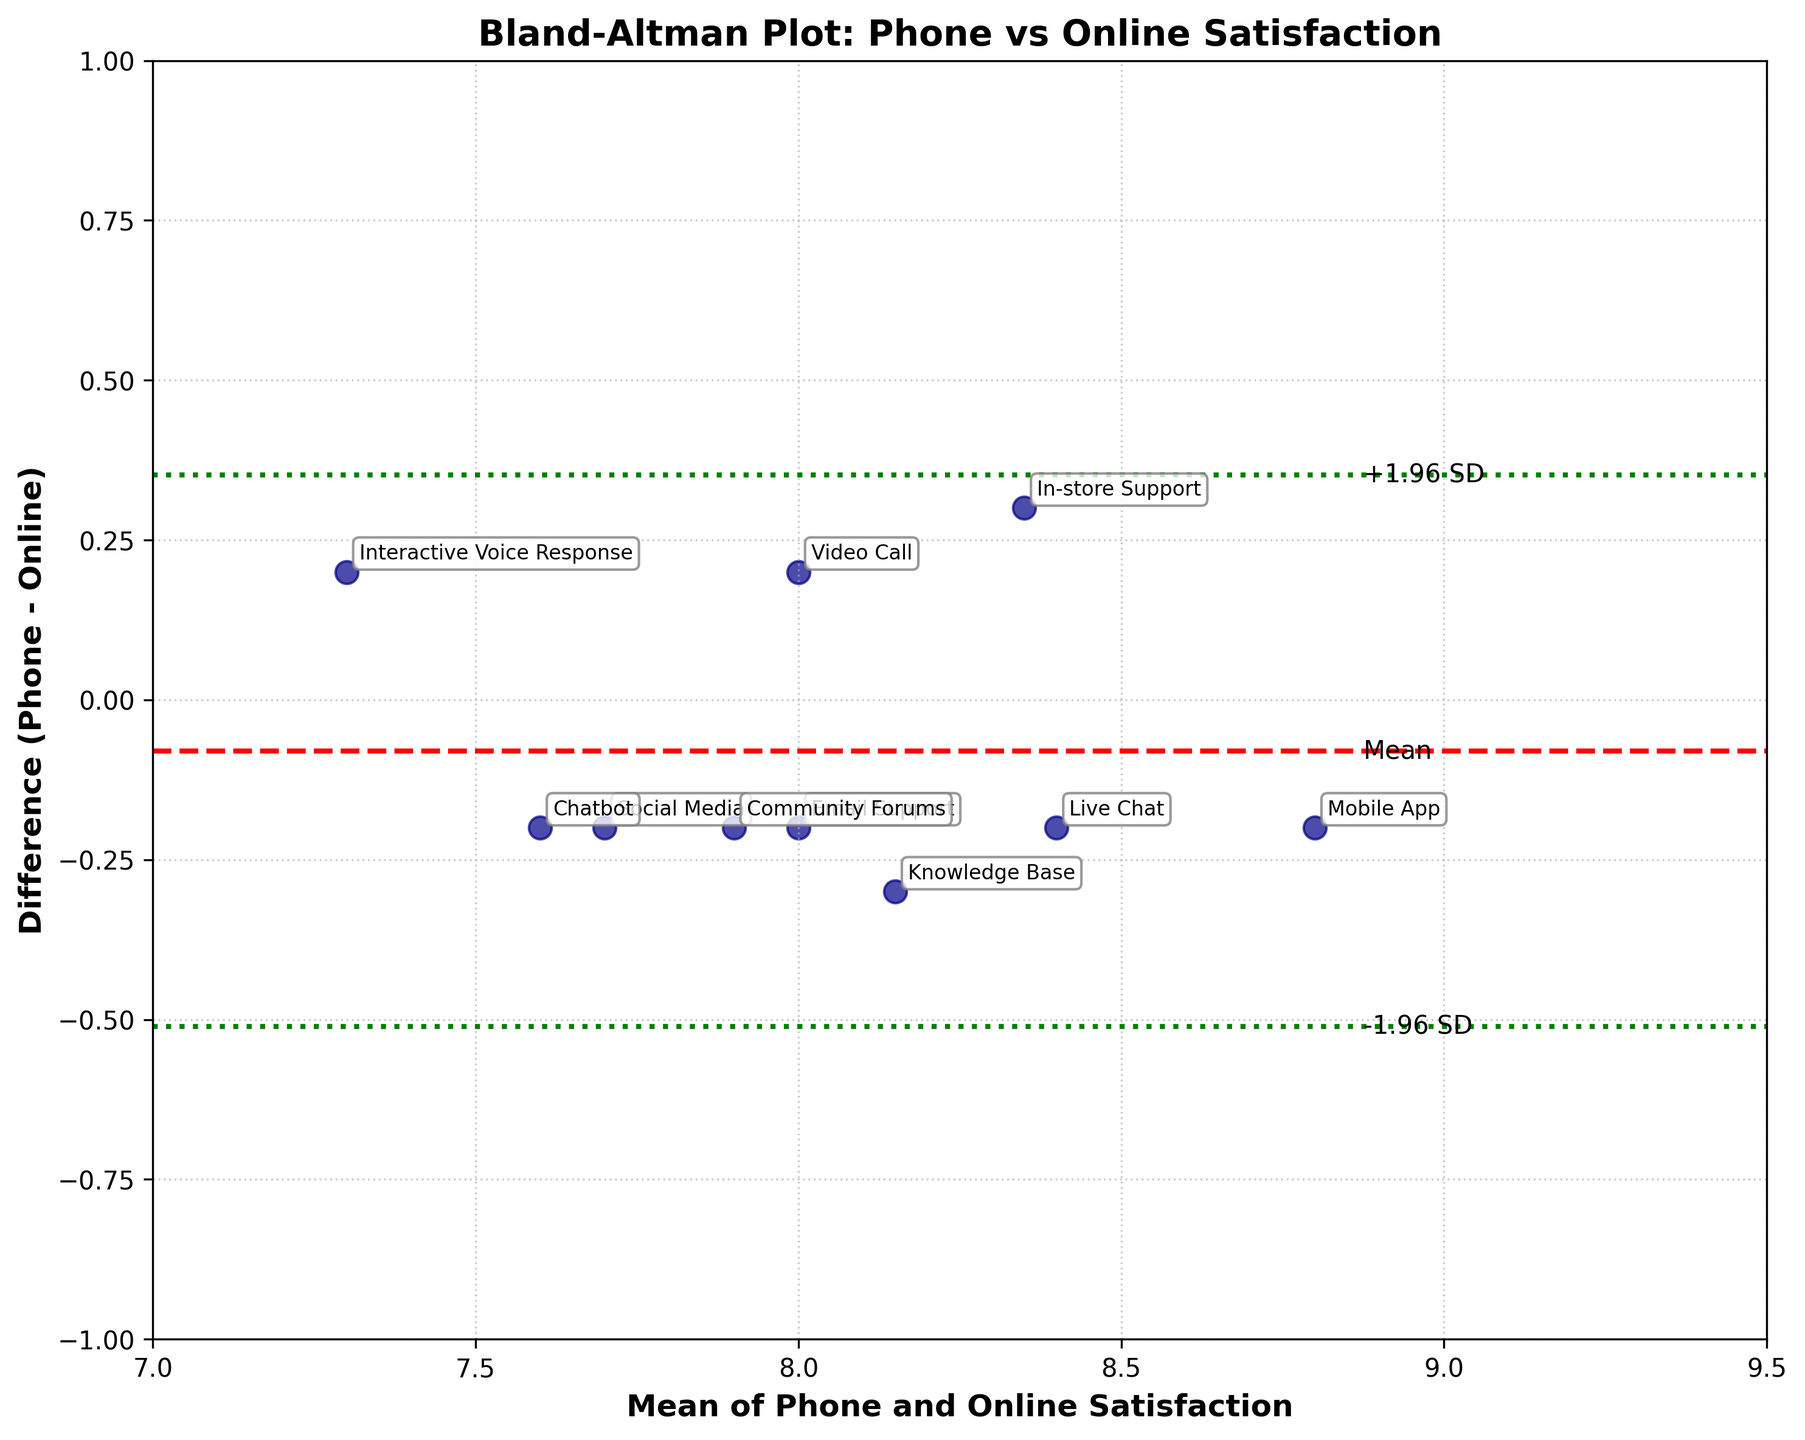What is the title of the plot? The title of the plot is prominently displayed at the top and reads "Bland-Altman Plot: Phone vs Online Satisfaction".
Answer: Bland-Altman Plot: Phone vs Online Satisfaction What is the mean difference between phone and online satisfaction scores? The mean difference is indicated by the red dashed horizontal line on the plot. A label "Mean" is positioned next to the line, representing the mean difference.
Answer: 0.0 What are the limits of agreement for the difference between phone and online satisfaction scores? The limits of agreement are denoted by green dotted horizontal lines. Labels "-1.96 SD" and "+1.96 SD" alongside these lines represent the lower and upper limits of agreement, respectively.
Answer: -0.30 and 0.30 Which service channel has the smallest difference between phone and online satisfaction scores? By examining the vertical positioning of the points, we can see that the "Mobile App" channel is closest to the zero-difference line, indicating the smallest difference between phone and online satisfaction scores.
Answer: Mobile App Are there any service channels where phone satisfaction scores are consistently higher than online satisfaction scores? By identifying points above the zero-difference line, we see that channels like "In-store Support" and "Interactive Voice Response" have higher phone satisfaction scores compared to online satisfaction scores.
Answer: Yes Which service channel has the largest discrepancy between phone and online satisfaction scores? The largest discrepancy is identified by the point farthest from the zero-difference line. "Interactive Voice Response" is the furthest point below the zero line, indicating the largest negative difference.
Answer: Interactive Voice Response What is the average satisfaction score for Social Media across phone and online channels? The average is calculated by adding the phone and online satisfaction scores for Social Media (7.6 + 7.8) and dividing by 2.
Answer: 7.7 How does the satisfaction difference for "Video Call" compare to the mean difference? The satisfaction difference for "Video Call" is found at -0.2 on the plot, which is below the mean difference indicated by the red dashed line at zero.
Answer: Below the mean difference Which axis shows the mean of phone and online satisfaction scores? The x-axis is labeled "Mean of Phone and Online Satisfaction," indicating this axis presents the mean.
Answer: x-axis How many service channels have a mean satisfaction score greater than 8.0? By counting the points to the right of the vertical line marking the mean score of 8.0, we identify 7 service channels: "In-store Support", "Live Chat", "Interactive Voice Response", "Mobile App", "Knowledge Base", "Community Forums", and "Chatbot".
Answer: 7 